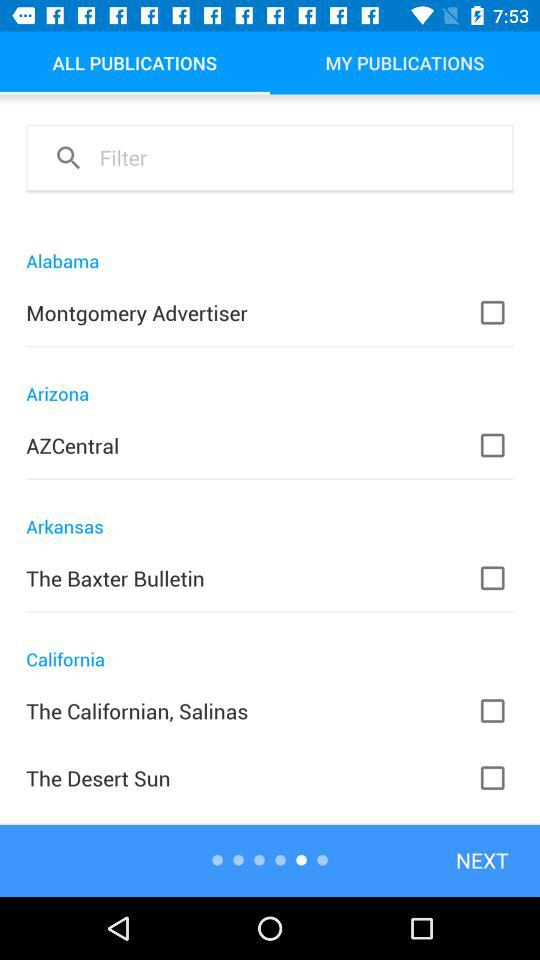How many publications are from California?
Answer the question using a single word or phrase. 2 